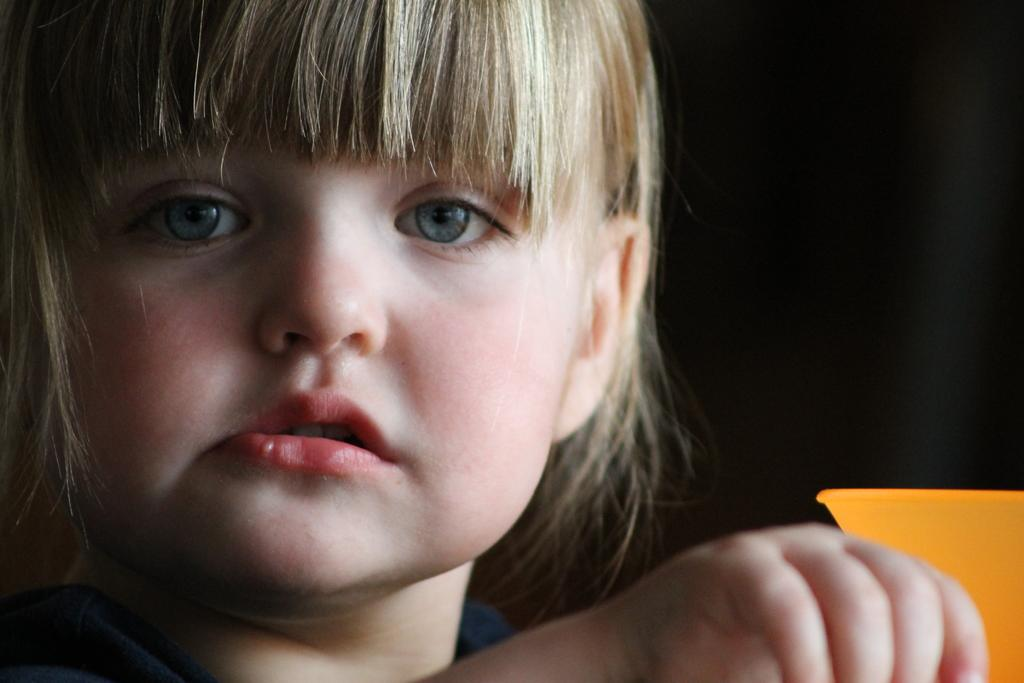Where is the girl located in the image? The girl is in the left corner of the picture. What is the girl doing in the image? The girl is looking at the camera. What object is beside the girl's hand? There is an orange-colored box beside the girl's hand. What color is the background of the image? The background of the image is black in color. Can you see the coastline in the image? There is no coastline visible in the image; the background is black. Is the queen present in the image? There is no queen depicted in the image; it features a girl looking at the camera. 